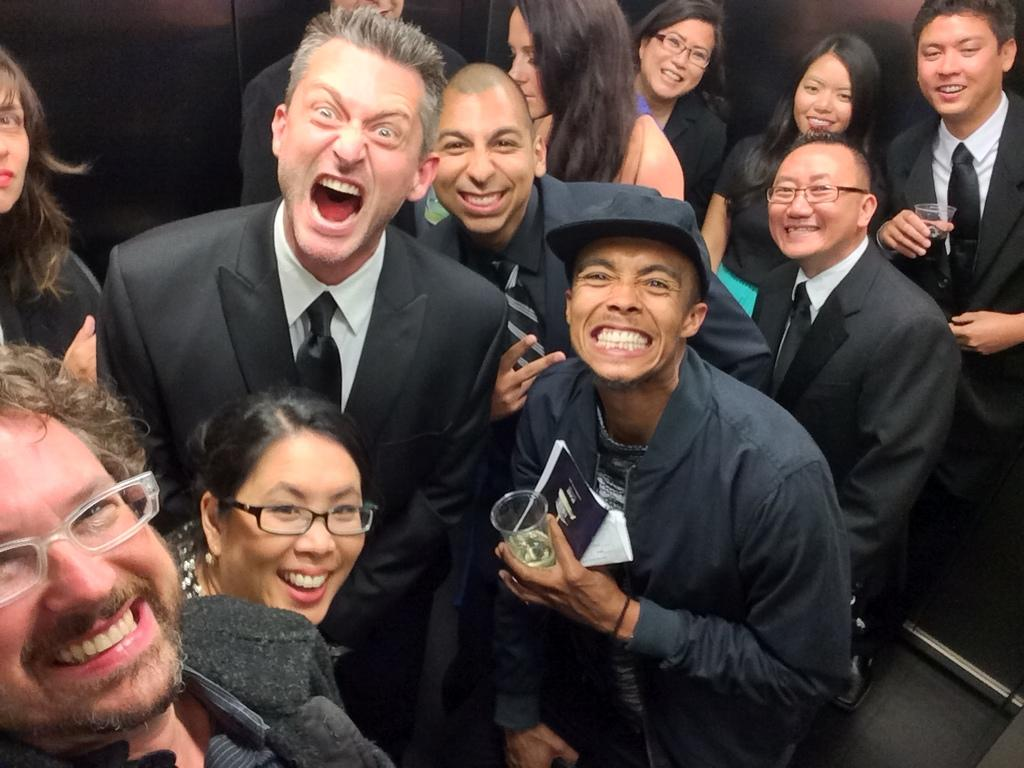What is happening in the image? There is a group of people in the image. What is the mood or expression of the people in the image? The people are smiling. What are two of the people holding in the image? Two persons are holding glasses. What type of distribution is being carried out by the people in the image? There is no indication of any distribution being carried out in the image; the people are simply holding glasses and smiling. 